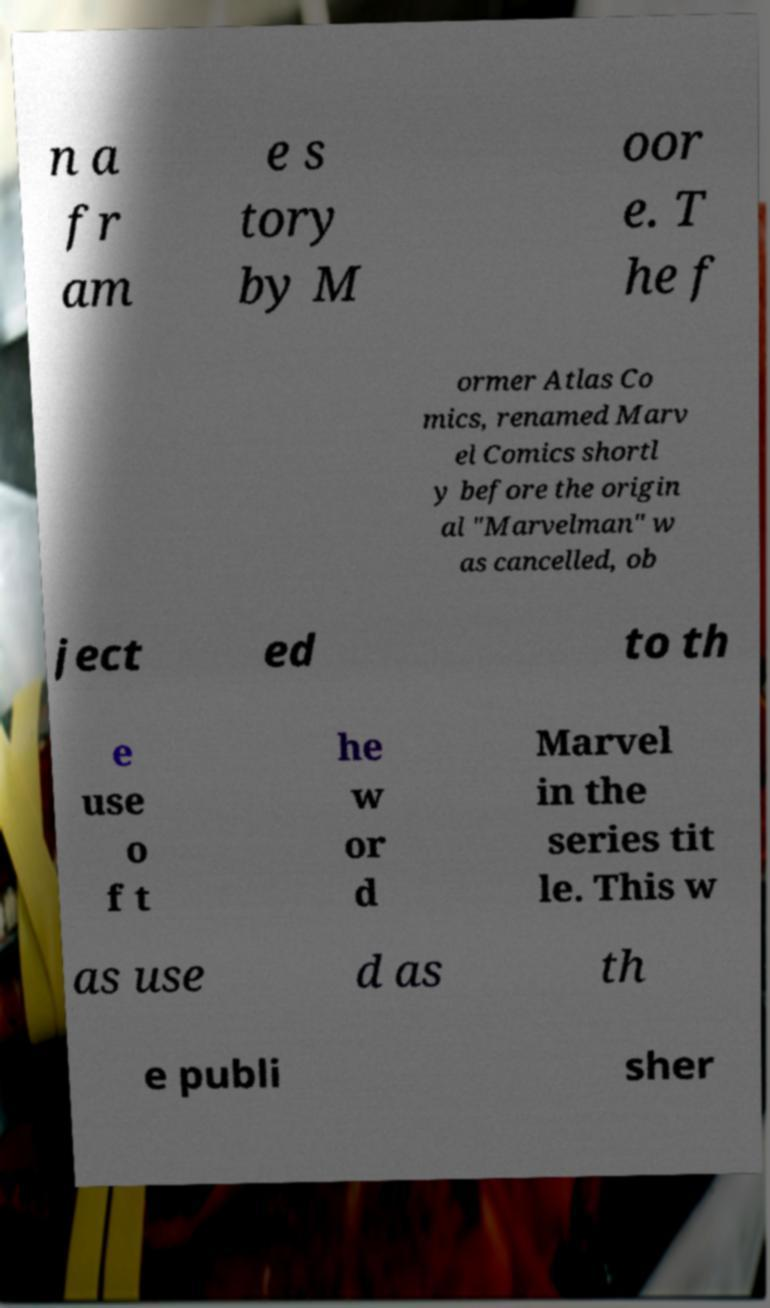I need the written content from this picture converted into text. Can you do that? n a fr am e s tory by M oor e. T he f ormer Atlas Co mics, renamed Marv el Comics shortl y before the origin al "Marvelman" w as cancelled, ob ject ed to th e use o f t he w or d Marvel in the series tit le. This w as use d as th e publi sher 